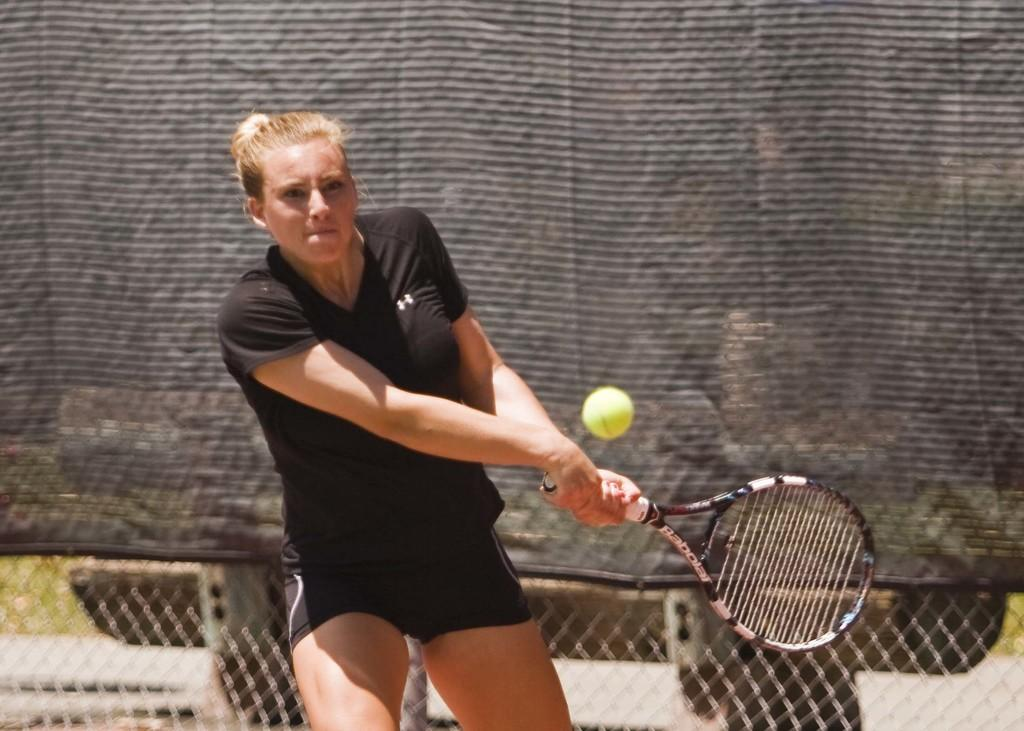What is the main subject of the image? There is a woman standing in the center of the image. What is the woman holding in the image? The woman is holding a racket. What can be seen in the background of the image? There is a sheet and a fence in the background of the image. How many boys are playing with the fruit in the image? There are no boys or fruit present in the image. What type of trade is being conducted in the image? There is no trade being conducted in the image; it features a woman holding a racket. 